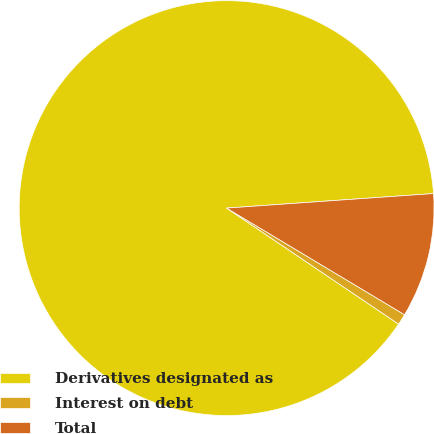<chart> <loc_0><loc_0><loc_500><loc_500><pie_chart><fcel>Derivatives designated as<fcel>Interest on debt<fcel>Total<nl><fcel>89.45%<fcel>0.85%<fcel>9.71%<nl></chart> 